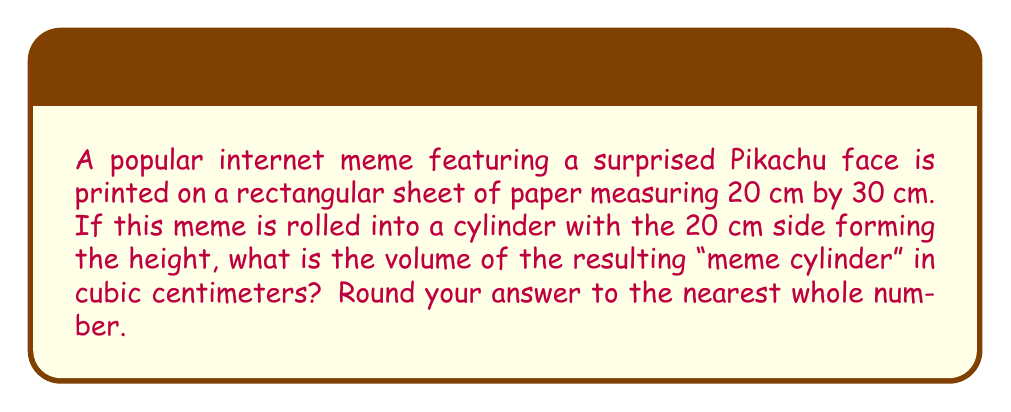Can you answer this question? Let's approach this step-by-step:

1) The cylinder's height (h) is the shorter side of the rectangle: 20 cm

2) The circumference of the base of the cylinder is the longer side of the rectangle: 30 cm

3) To find the radius (r) of the base, we use the formula for circumference:
   $$ C = 2\pi r $$
   $$ 30 = 2\pi r $$
   $$ r = \frac{30}{2\pi} \approx 4.77 \text{ cm} $$

4) Now we have the radius and height. The volume of a cylinder is given by the formula:
   $$ V = \pi r^2 h $$

5) Substituting our values:
   $$ V = \pi (4.77)^2 (20) $$
   $$ V \approx 1430.20 \text{ cm}^3 $$

6) Rounding to the nearest whole number:
   $$ V \approx 1430 \text{ cm}^3 $$

[asy]
import geometry;

// Draw cylinder
pair O=(0,0);
real r=2;
real h=4;
path p=circle(O,r);
draw(p);
draw((r,0)--(r,h));
draw((-r,0)--(-r,h),dashed);
draw(shift(0,h)*p);

// Label
label("h", (r+0.2,h/2));
label("r", (r/2,-0.2));
</asy]
Answer: $1430 \text{ cm}^3$ 